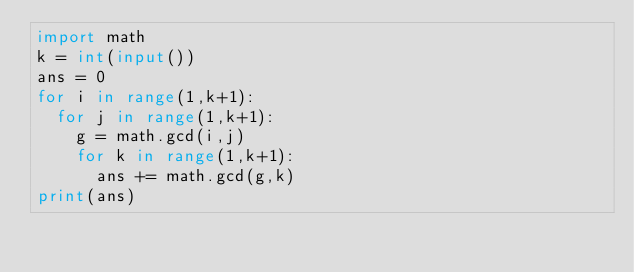Convert code to text. <code><loc_0><loc_0><loc_500><loc_500><_Python_>import math
k = int(input())
ans = 0
for i in range(1,k+1):
  for j in range(1,k+1):
    g = math.gcd(i,j)
    for k in range(1,k+1):
      ans += math.gcd(g,k)
print(ans)</code> 